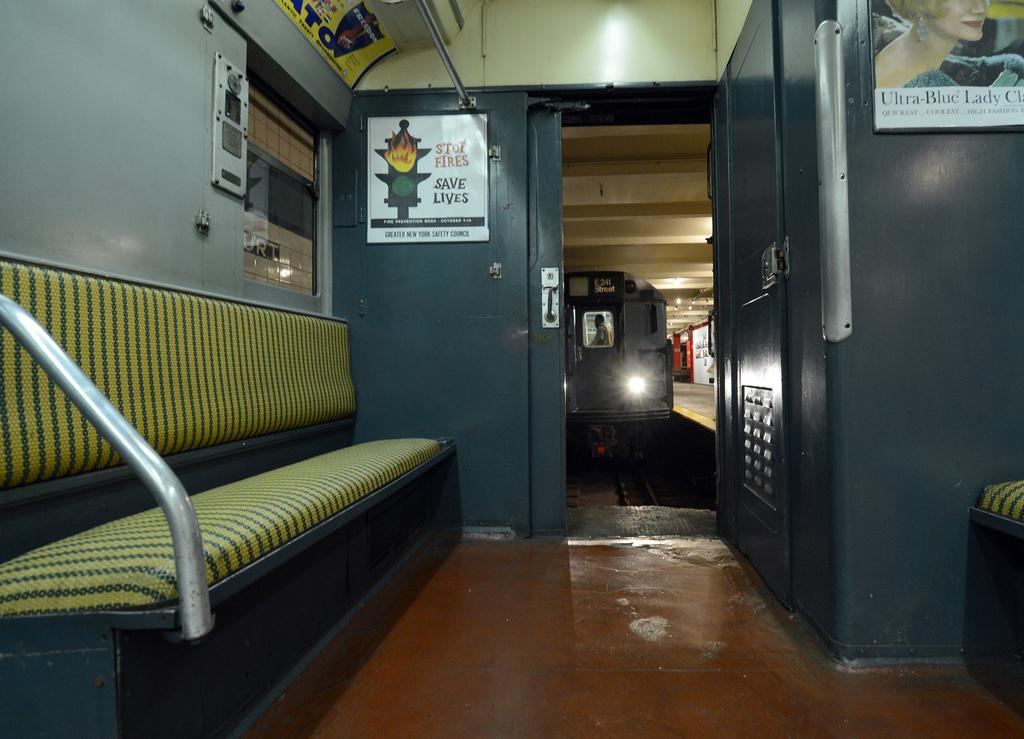<image>
Describe the image concisely. A sign on a door reads Stop Fires Save Lives. 